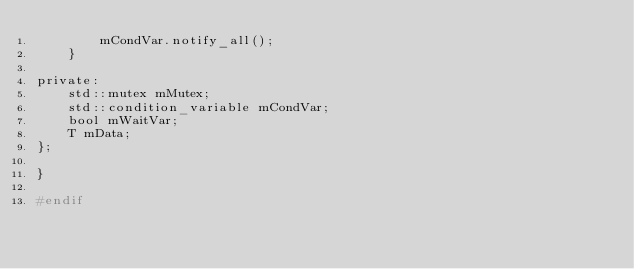<code> <loc_0><loc_0><loc_500><loc_500><_C_>        mCondVar.notify_all();
    }

private:
    std::mutex mMutex;
    std::condition_variable mCondVar;
    bool mWaitVar;
    T mData;
};

}

#endif
</code> 